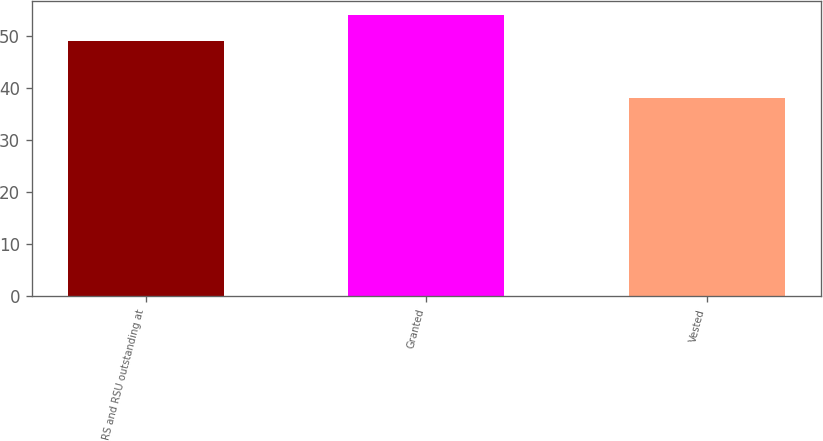<chart> <loc_0><loc_0><loc_500><loc_500><bar_chart><fcel>RS and RSU outstanding at<fcel>Granted<fcel>Vested<nl><fcel>49<fcel>54<fcel>38<nl></chart> 